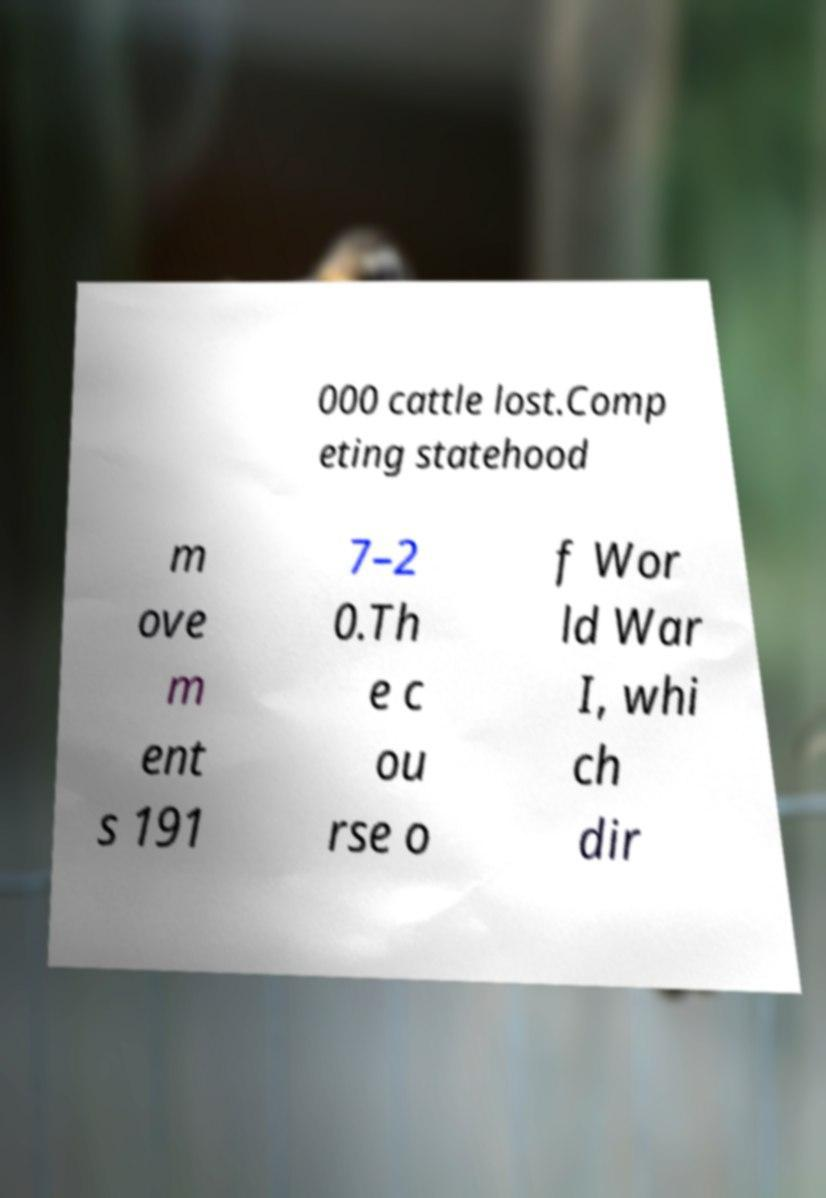I need the written content from this picture converted into text. Can you do that? 000 cattle lost.Comp eting statehood m ove m ent s 191 7–2 0.Th e c ou rse o f Wor ld War I, whi ch dir 